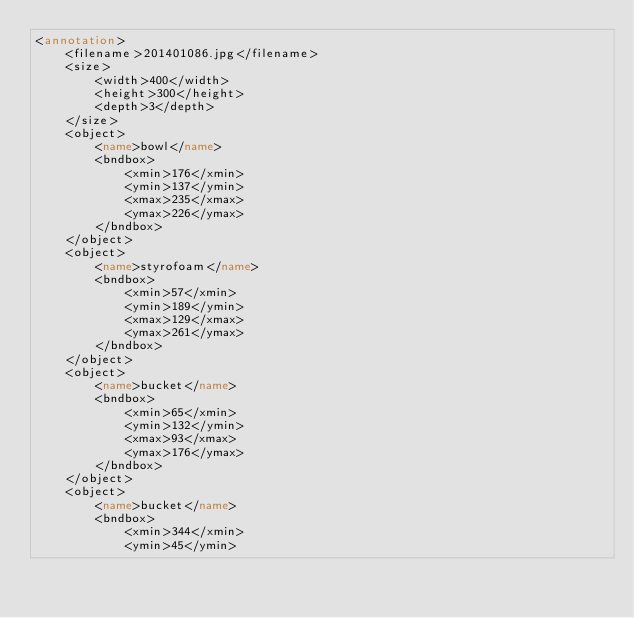<code> <loc_0><loc_0><loc_500><loc_500><_XML_><annotation>
	<filename>201401086.jpg</filename>
	<size>
		<width>400</width>
		<height>300</height>
		<depth>3</depth>
	</size>
	<object>
		<name>bowl</name>
		<bndbox>
			<xmin>176</xmin>
			<ymin>137</ymin>
			<xmax>235</xmax>
			<ymax>226</ymax>
		</bndbox>
	</object>
	<object>
		<name>styrofoam</name>
		<bndbox>
			<xmin>57</xmin>
			<ymin>189</ymin>
			<xmax>129</xmax>
			<ymax>261</ymax>
		</bndbox>
	</object>
	<object>
		<name>bucket</name>
		<bndbox>
			<xmin>65</xmin>
			<ymin>132</ymin>
			<xmax>93</xmax>
			<ymax>176</ymax>
		</bndbox>
	</object>
	<object>
		<name>bucket</name>
		<bndbox>
			<xmin>344</xmin>
			<ymin>45</ymin></code> 